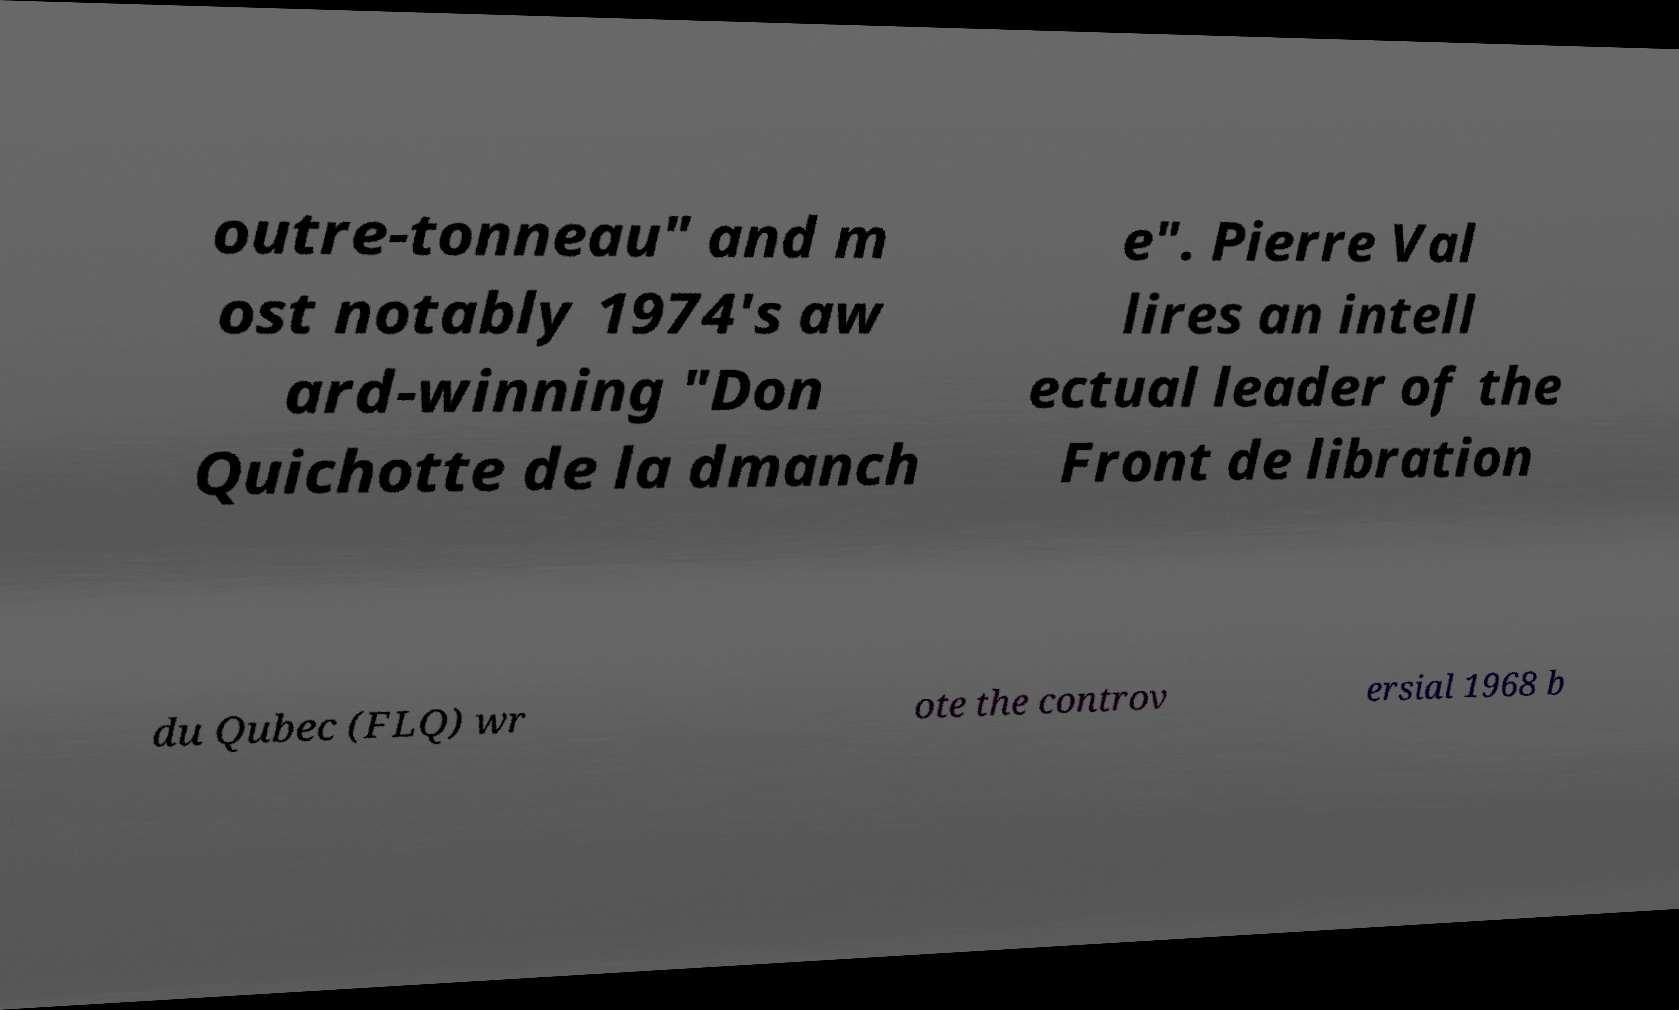Please identify and transcribe the text found in this image. outre-tonneau" and m ost notably 1974's aw ard-winning "Don Quichotte de la dmanch e". Pierre Val lires an intell ectual leader of the Front de libration du Qubec (FLQ) wr ote the controv ersial 1968 b 